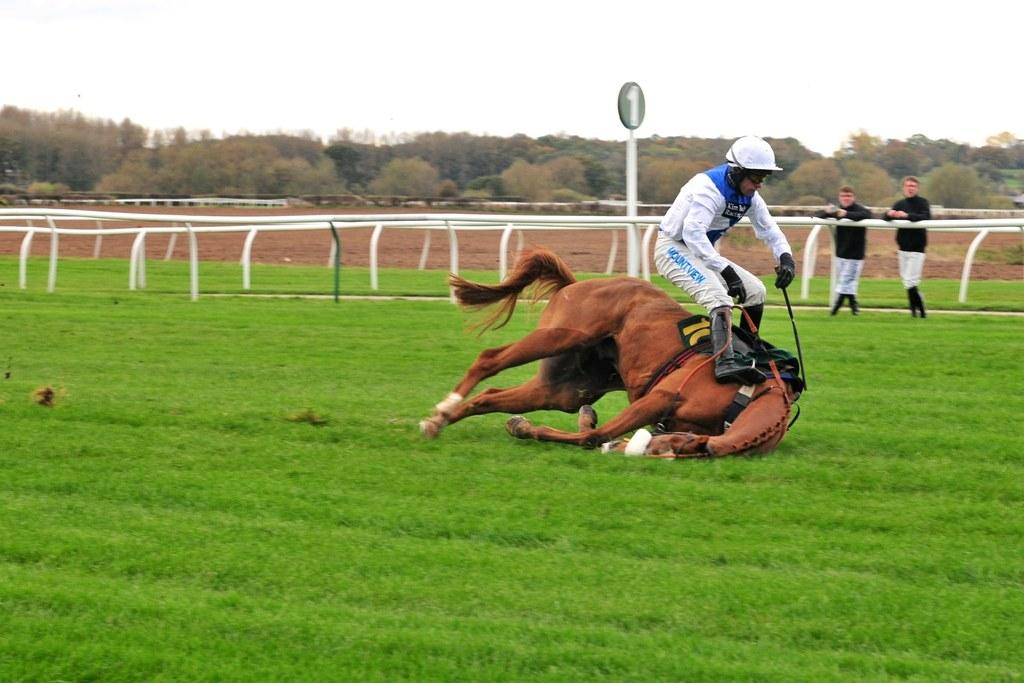Who is present in the image? There is a man and a horse in the image. What is the setting of the image? The man and the horse are on grassland. What is the man's posture in the image? The man appears to be about to fall. Can you describe the background of the image? There are people, a boundary, trees, and the sky visible in the background of the image. What date is marked on the calendar in the image? There is no calendar present in the image. Can you describe the zebra's behavior in the image? There is no zebra present in the image. 